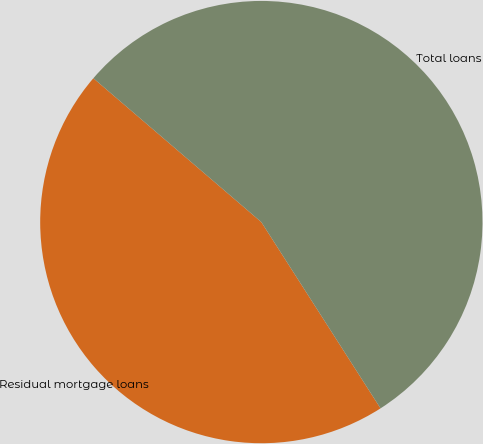Convert chart. <chart><loc_0><loc_0><loc_500><loc_500><pie_chart><fcel>Residual mortgage loans<fcel>Total loans<nl><fcel>45.33%<fcel>54.67%<nl></chart> 